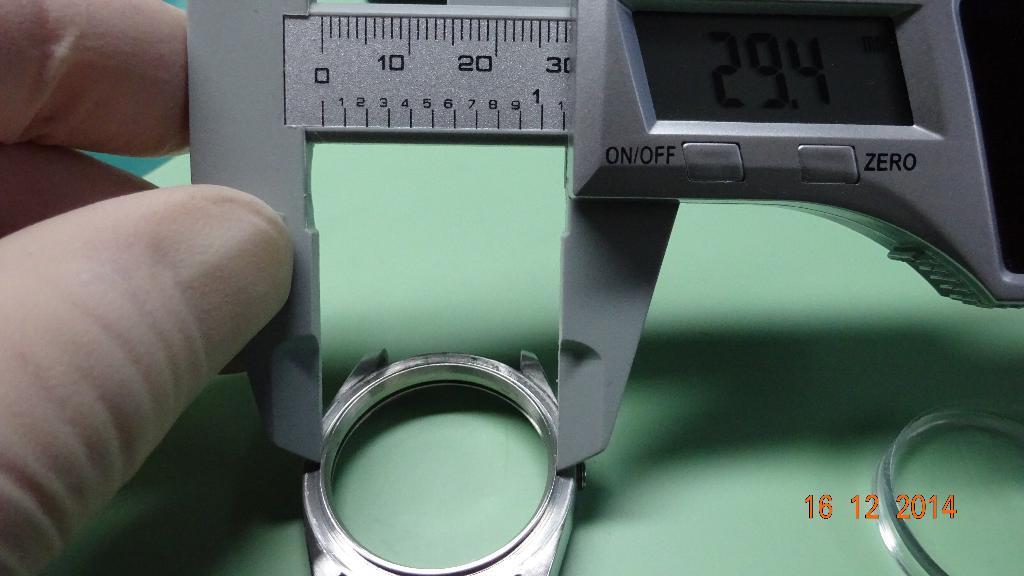Please provide a concise description of this image. In the image there is a person holding vernier calipers measuring diameter of a ring on a table. 